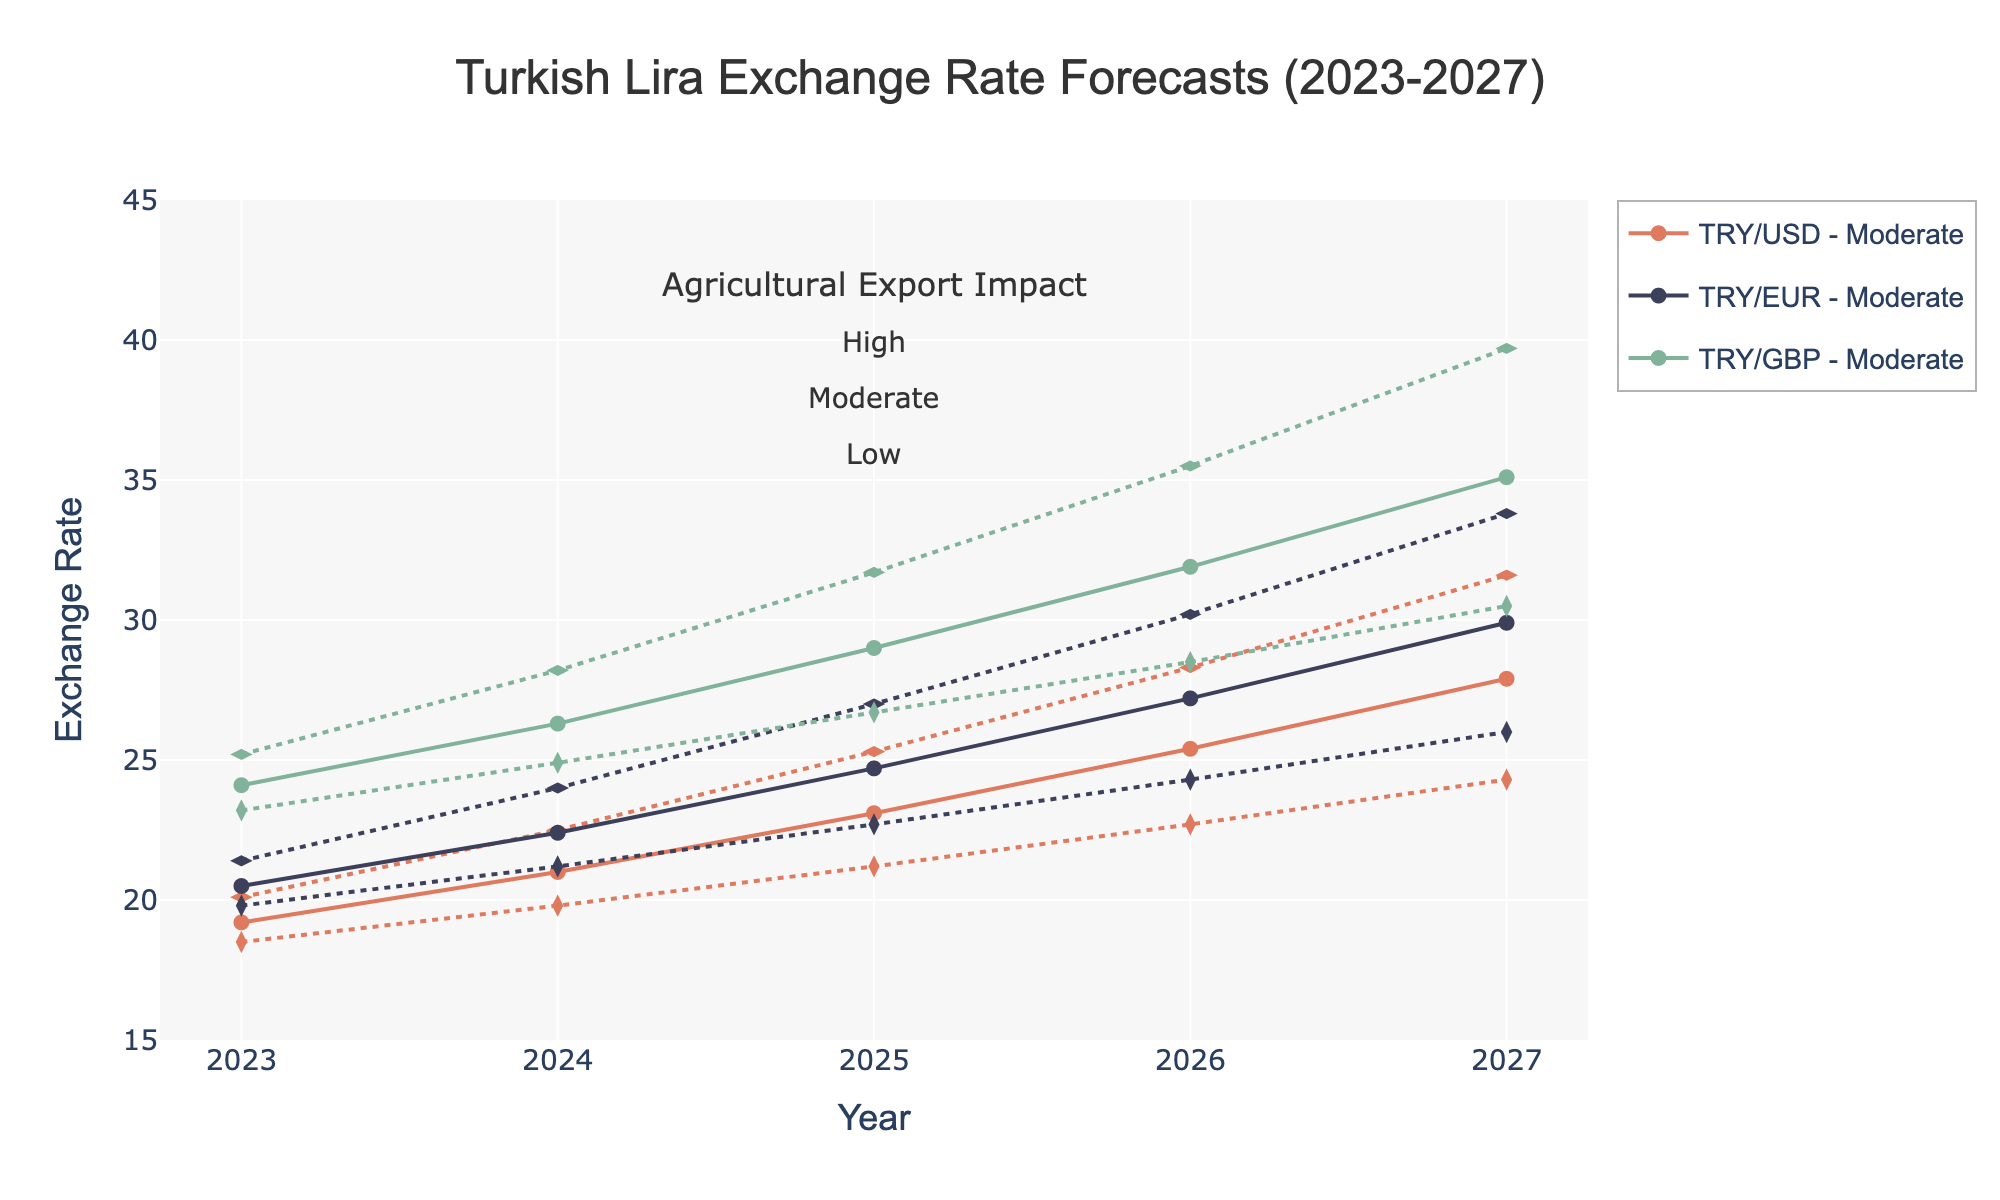What's the title of the figure? The title is typically displayed at the top of the figure. From the provided code, we see it mentions 'Turkish Lira Exchange Rate Forecasts (2023-2027)'.
Answer: Turkish Lira Exchange Rate Forecasts (2023-2027) How many different scenarios are shown in the chart? Each year has three different scenarios represented (Optimistic, Moderate, Pessimistic), which can be identified by different line styles and markers.
Answer: Three Which year shows the highest exchange rate of TRY/USD under a pessimistic scenario? This requires identifying the TRY/USD values under the pessimistic scenario for each year, then finding the maximum value among them.
Answer: 2027 What's the exchange rate of TRY/EUR in 2025 under the optimistic scenario? Finding TRY/EUR values for the optimistic scenario in the year 2025 will give us this information.
Answer: 22.7 How does the agricultural export impact vary among scenarios in a single year, for example, in 2026? Agricultural export impact is indicated along with each scenario: high for optimistic, moderate for moderate, and low for pessimistic. This can be noted from the consistent pattern of impacts.
Answer: High, Moderate, and Low What is the average exchange rate of TRY/GBP for the moderate scenario across all years? To find this, look at the TRY/GBP values under the moderate scenario for each year and calculate their average: (24.1 + 26.3 + 29.0 + 31.9 + 35.1) / 5.
Answer: 29.28 Compare the TRY/USD exchange rates between the optimistic and pessimistic scenarios in 2025. Identify the TRY/USD values for both optimistic and pessimistic scenarios in 2025 and compare them. Optimistic is 21.2, and pessimistic is 25.3. 25.3 > 21.2.
Answer: Pessimistic higher than Optimistic What is the range of TRY/GBP exchange rates in 2024 across all scenarios? Find the minimum and maximum TRY/GBP values in 2024 for all scenarios: Optimistic (24.9), Moderate (26.3), Pessimistic (28.2). Range = max - min.
Answer: 3.3 What pattern can you observe about the TRY/EUR exchange rates from 2023 to 2027 under the moderate scenario? Track the TRY/EUR rates for the moderate scenario for each year: starting from 20.5 in 2023, it increases steadily each year.
Answer: Increasing Based on the trend, what can you infer about the impact of agricultural exports on the exchange rate for the pessimistic scenario by 2027? Since low agricultural exports correspond to high exchange rates, as seen in the increasing TRY/USD, TRY/EUR, and TRY/GBP values, low impact negatively affects the exchange rate.
Answer: Negative impact 